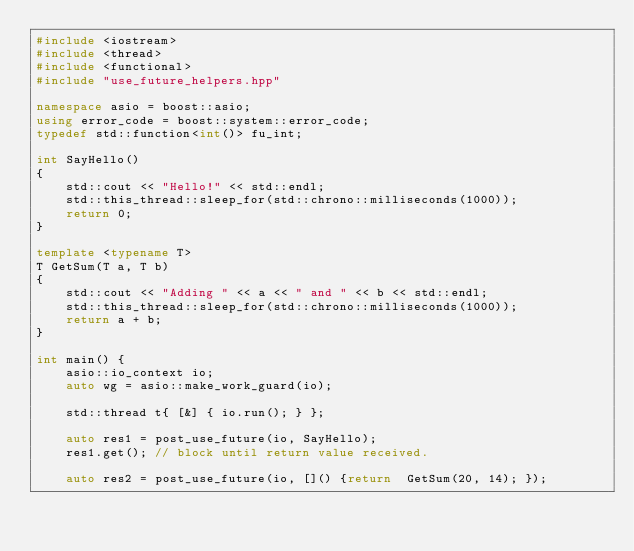<code> <loc_0><loc_0><loc_500><loc_500><_C++_>#include <iostream>
#include <thread>
#include <functional>
#include "use_future_helpers.hpp"

namespace asio = boost::asio;
using error_code = boost::system::error_code;
typedef std::function<int()> fu_int;

int SayHello()
{
	std::cout << "Hello!" << std::endl;
	std::this_thread::sleep_for(std::chrono::milliseconds(1000));
	return 0;
}

template <typename T>
T GetSum(T a, T b)
{
	std::cout << "Adding " << a << " and " << b << std::endl;
	std::this_thread::sleep_for(std::chrono::milliseconds(1000));
	return a + b;
}

int main() {
	asio::io_context io;
	auto wg = asio::make_work_guard(io);

	std::thread t{ [&] { io.run(); } };
		
	auto res1 = post_use_future(io, SayHello);
	res1.get(); // block until return value received.
	
	auto res2 = post_use_future(io, []() {return  GetSum(20, 14); });</code> 